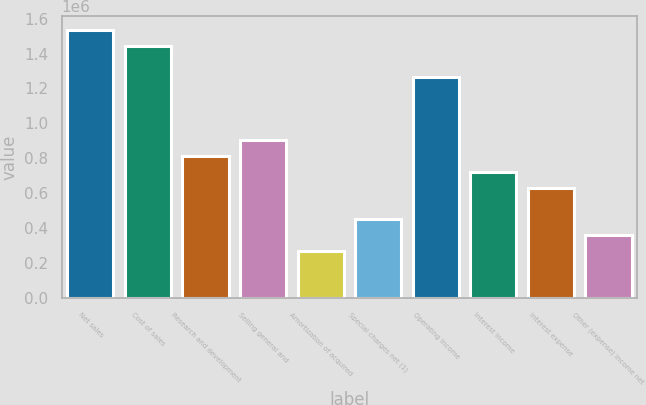<chart> <loc_0><loc_0><loc_500><loc_500><bar_chart><fcel>Net sales<fcel>Cost of sales<fcel>Research and development<fcel>Selling general and<fcel>Amortization of acquired<fcel>Special charges net (1)<fcel>Operating income<fcel>Interest income<fcel>Interest expense<fcel>Other (expense) income net<nl><fcel>1.5356e+06<fcel>1.44527e+06<fcel>812967<fcel>903297<fcel>270990<fcel>451649<fcel>1.26462e+06<fcel>722638<fcel>632308<fcel>361320<nl></chart> 